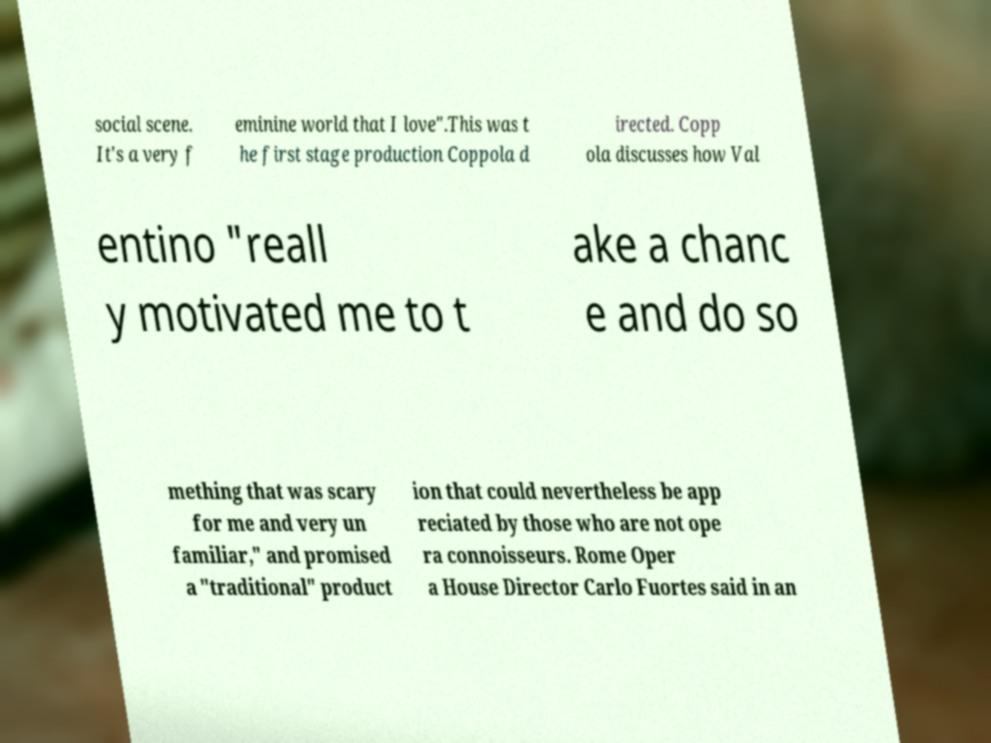What messages or text are displayed in this image? I need them in a readable, typed format. social scene. It's a very f eminine world that I love".This was t he first stage production Coppola d irected. Copp ola discusses how Val entino "reall y motivated me to t ake a chanc e and do so mething that was scary for me and very un familiar," and promised a "traditional" product ion that could nevertheless be app reciated by those who are not ope ra connoisseurs. Rome Oper a House Director Carlo Fuortes said in an 